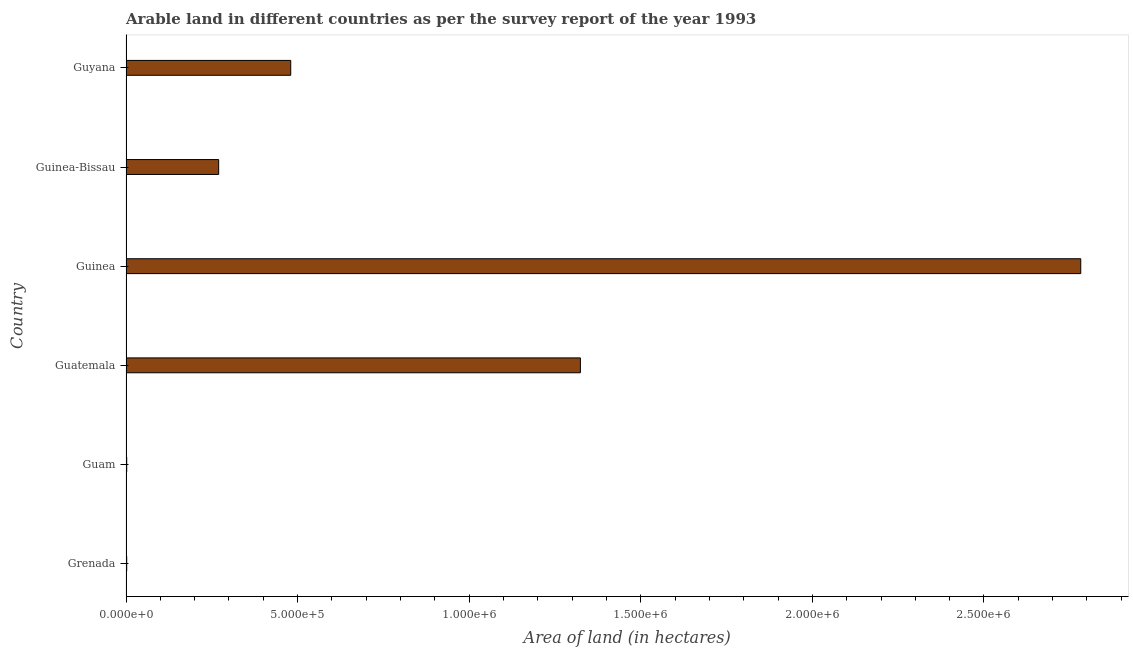What is the title of the graph?
Give a very brief answer. Arable land in different countries as per the survey report of the year 1993. What is the label or title of the X-axis?
Keep it short and to the point. Area of land (in hectares). What is the label or title of the Y-axis?
Provide a succinct answer. Country. What is the area of land in Guyana?
Offer a very short reply. 4.80e+05. Across all countries, what is the maximum area of land?
Make the answer very short. 2.78e+06. In which country was the area of land maximum?
Your response must be concise. Guinea. In which country was the area of land minimum?
Your response must be concise. Grenada. What is the sum of the area of land?
Provide a short and direct response. 4.86e+06. What is the difference between the area of land in Guinea and Guinea-Bissau?
Your answer should be very brief. 2.51e+06. What is the average area of land per country?
Make the answer very short. 8.10e+05. What is the median area of land?
Keep it short and to the point. 3.75e+05. In how many countries, is the area of land greater than 300000 hectares?
Your answer should be compact. 3. What is the ratio of the area of land in Guinea-Bissau to that in Guyana?
Ensure brevity in your answer.  0.56. Is the area of land in Guam less than that in Guinea?
Offer a terse response. Yes. What is the difference between the highest and the second highest area of land?
Offer a terse response. 1.46e+06. Is the sum of the area of land in Guinea and Guinea-Bissau greater than the maximum area of land across all countries?
Give a very brief answer. Yes. What is the difference between the highest and the lowest area of land?
Your answer should be compact. 2.78e+06. In how many countries, is the area of land greater than the average area of land taken over all countries?
Give a very brief answer. 2. How many countries are there in the graph?
Your answer should be compact. 6. Are the values on the major ticks of X-axis written in scientific E-notation?
Keep it short and to the point. Yes. What is the Area of land (in hectares) in Grenada?
Keep it short and to the point. 2000. What is the Area of land (in hectares) of Guam?
Your answer should be very brief. 2000. What is the Area of land (in hectares) in Guatemala?
Your response must be concise. 1.32e+06. What is the Area of land (in hectares) in Guinea?
Keep it short and to the point. 2.78e+06. What is the Area of land (in hectares) in Guyana?
Your response must be concise. 4.80e+05. What is the difference between the Area of land (in hectares) in Grenada and Guatemala?
Keep it short and to the point. -1.32e+06. What is the difference between the Area of land (in hectares) in Grenada and Guinea?
Provide a short and direct response. -2.78e+06. What is the difference between the Area of land (in hectares) in Grenada and Guinea-Bissau?
Keep it short and to the point. -2.68e+05. What is the difference between the Area of land (in hectares) in Grenada and Guyana?
Offer a very short reply. -4.78e+05. What is the difference between the Area of land (in hectares) in Guam and Guatemala?
Your answer should be very brief. -1.32e+06. What is the difference between the Area of land (in hectares) in Guam and Guinea?
Keep it short and to the point. -2.78e+06. What is the difference between the Area of land (in hectares) in Guam and Guinea-Bissau?
Provide a succinct answer. -2.68e+05. What is the difference between the Area of land (in hectares) in Guam and Guyana?
Offer a very short reply. -4.78e+05. What is the difference between the Area of land (in hectares) in Guatemala and Guinea?
Your response must be concise. -1.46e+06. What is the difference between the Area of land (in hectares) in Guatemala and Guinea-Bissau?
Offer a very short reply. 1.05e+06. What is the difference between the Area of land (in hectares) in Guatemala and Guyana?
Keep it short and to the point. 8.44e+05. What is the difference between the Area of land (in hectares) in Guinea and Guinea-Bissau?
Keep it short and to the point. 2.51e+06. What is the difference between the Area of land (in hectares) in Guinea and Guyana?
Keep it short and to the point. 2.30e+06. What is the difference between the Area of land (in hectares) in Guinea-Bissau and Guyana?
Offer a terse response. -2.10e+05. What is the ratio of the Area of land (in hectares) in Grenada to that in Guam?
Give a very brief answer. 1. What is the ratio of the Area of land (in hectares) in Grenada to that in Guatemala?
Your answer should be very brief. 0. What is the ratio of the Area of land (in hectares) in Grenada to that in Guinea-Bissau?
Keep it short and to the point. 0.01. What is the ratio of the Area of land (in hectares) in Grenada to that in Guyana?
Make the answer very short. 0. What is the ratio of the Area of land (in hectares) in Guam to that in Guatemala?
Keep it short and to the point. 0. What is the ratio of the Area of land (in hectares) in Guam to that in Guinea?
Give a very brief answer. 0. What is the ratio of the Area of land (in hectares) in Guam to that in Guinea-Bissau?
Give a very brief answer. 0.01. What is the ratio of the Area of land (in hectares) in Guam to that in Guyana?
Your answer should be compact. 0. What is the ratio of the Area of land (in hectares) in Guatemala to that in Guinea?
Provide a short and direct response. 0.48. What is the ratio of the Area of land (in hectares) in Guatemala to that in Guinea-Bissau?
Your answer should be compact. 4.9. What is the ratio of the Area of land (in hectares) in Guatemala to that in Guyana?
Give a very brief answer. 2.76. What is the ratio of the Area of land (in hectares) in Guinea to that in Guinea-Bissau?
Make the answer very short. 10.3. What is the ratio of the Area of land (in hectares) in Guinea to that in Guyana?
Offer a very short reply. 5.8. What is the ratio of the Area of land (in hectares) in Guinea-Bissau to that in Guyana?
Offer a very short reply. 0.56. 